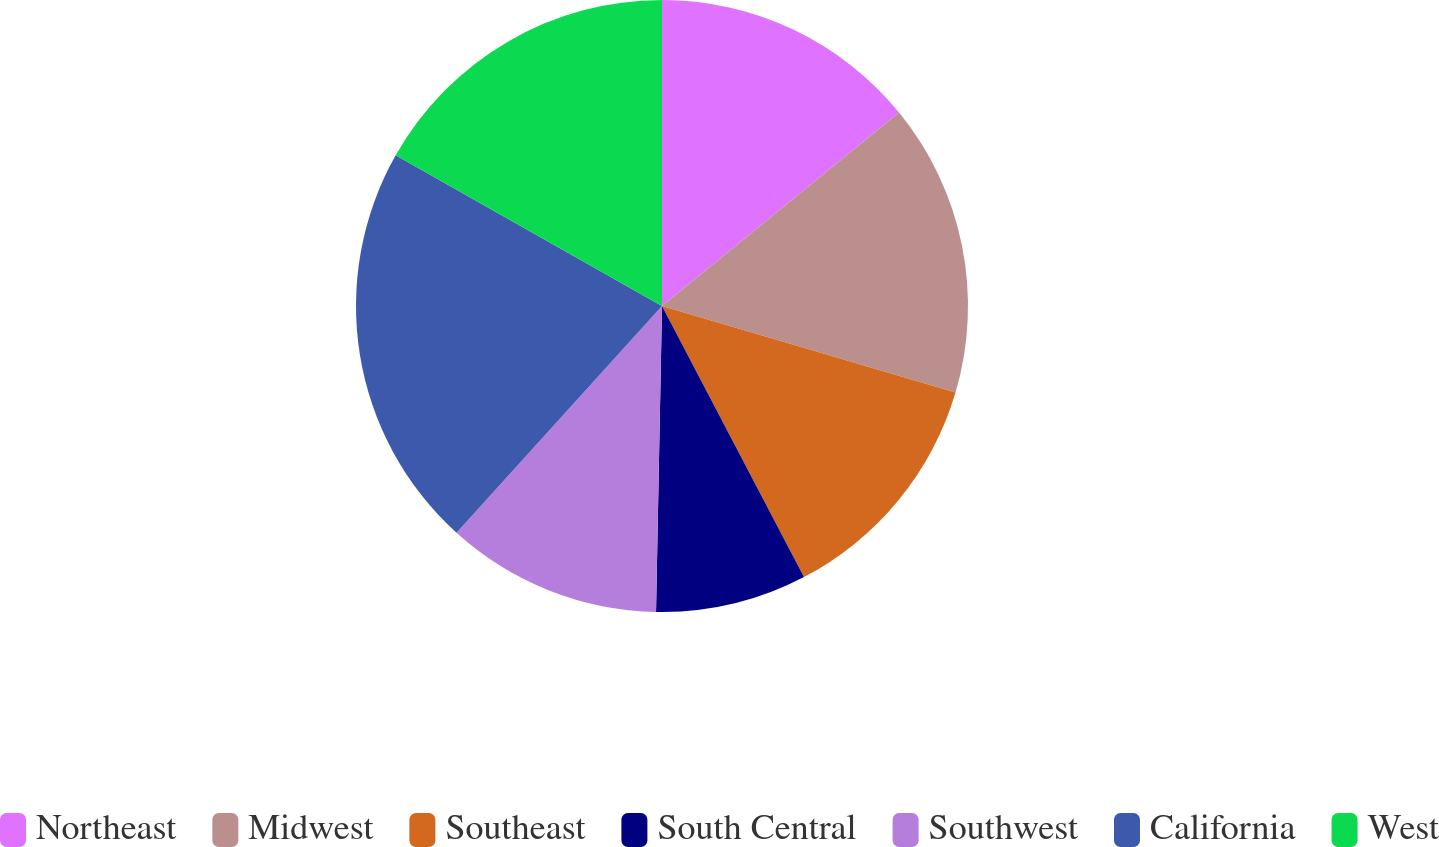Convert chart to OTSL. <chart><loc_0><loc_0><loc_500><loc_500><pie_chart><fcel>Northeast<fcel>Midwest<fcel>Southeast<fcel>South Central<fcel>Southwest<fcel>California<fcel>West<nl><fcel>14.11%<fcel>15.46%<fcel>12.76%<fcel>7.99%<fcel>11.41%<fcel>21.48%<fcel>16.81%<nl></chart> 